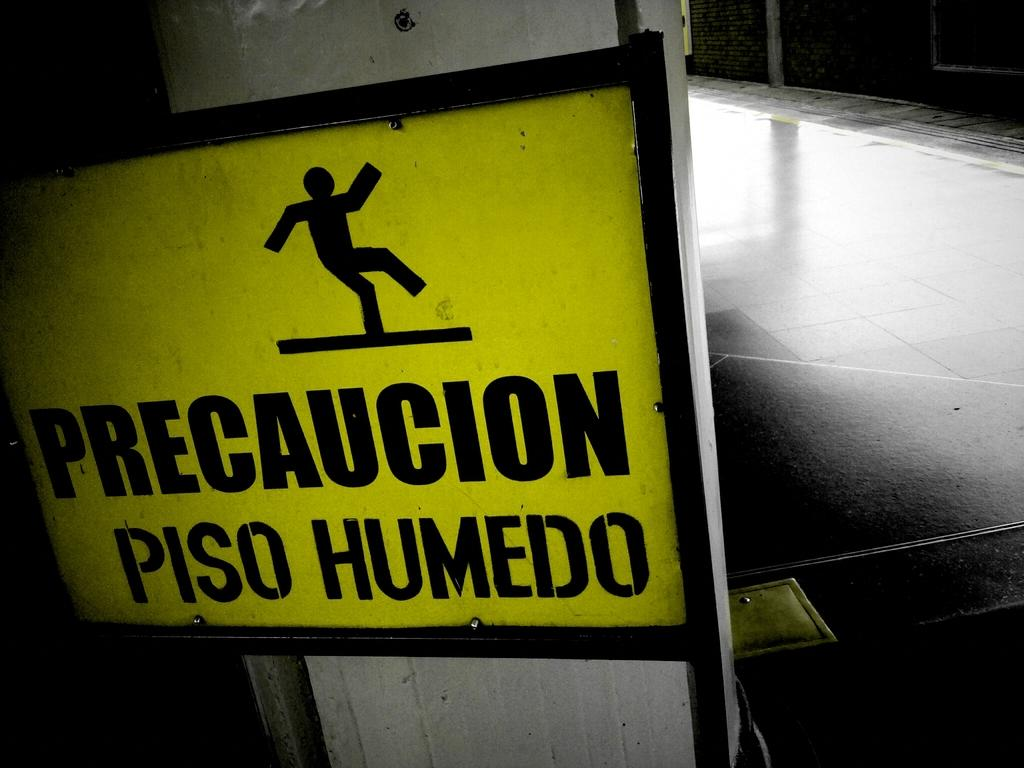What is the main object in the image? There is a precaution board in the image. How is the precaution board attached to the pillar? The precaution board is fixed to a pillar. What can be seen on the right side of the image? There is a floor on the right side of the image. What type of fruit is being shared among friends in the image? There is no fruit or friends present in the image; it features a precaution board fixed to a pillar and a floor on the right side. 